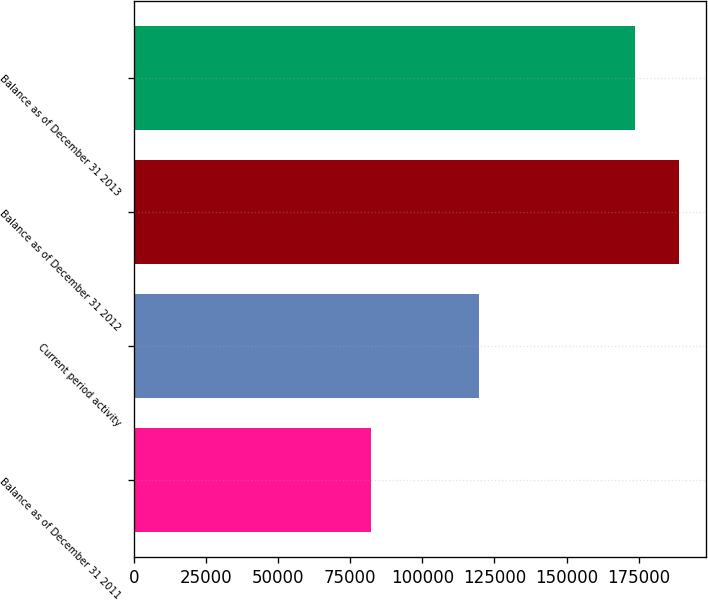Convert chart. <chart><loc_0><loc_0><loc_500><loc_500><bar_chart><fcel>Balance as of December 31 2011<fcel>Current period activity<fcel>Balance as of December 31 2012<fcel>Balance as of December 31 2013<nl><fcel>82043<fcel>119652<fcel>188803<fcel>173872<nl></chart> 